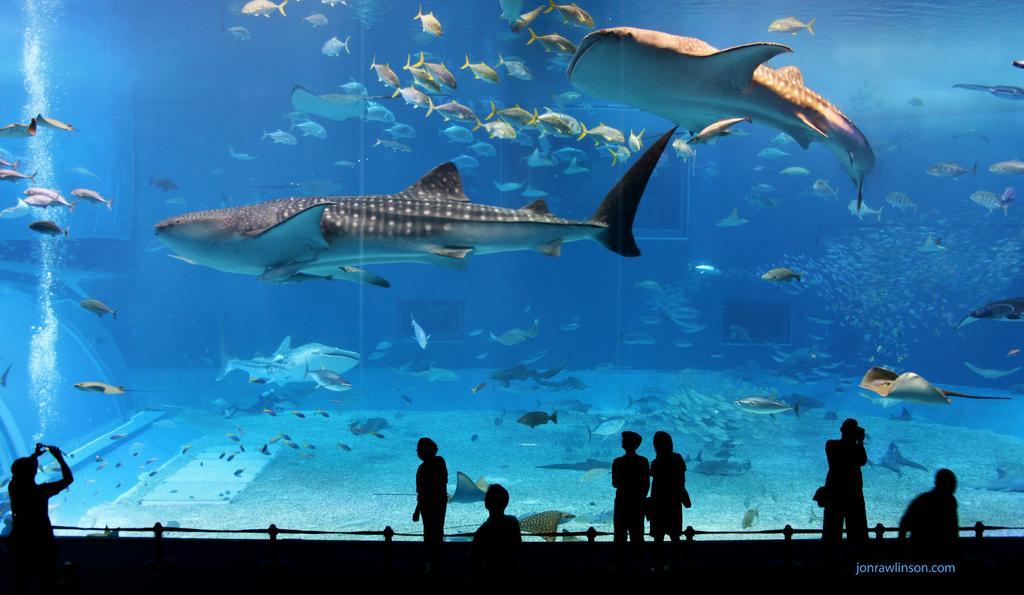In one or two sentences, can you explain what this image depicts? In this image, we can see an aquarium with water and fishes. At the bottom, we can see a group of people. Right side bottom, there is a watermark in the image. 